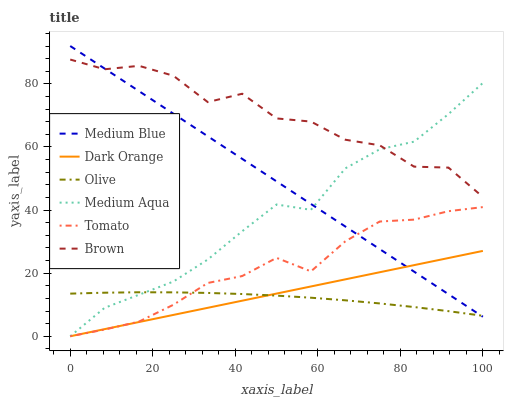Does Olive have the minimum area under the curve?
Answer yes or no. Yes. Does Brown have the maximum area under the curve?
Answer yes or no. Yes. Does Dark Orange have the minimum area under the curve?
Answer yes or no. No. Does Dark Orange have the maximum area under the curve?
Answer yes or no. No. Is Dark Orange the smoothest?
Answer yes or no. Yes. Is Brown the roughest?
Answer yes or no. Yes. Is Brown the smoothest?
Answer yes or no. No. Is Dark Orange the roughest?
Answer yes or no. No. Does Tomato have the lowest value?
Answer yes or no. Yes. Does Brown have the lowest value?
Answer yes or no. No. Does Medium Blue have the highest value?
Answer yes or no. Yes. Does Dark Orange have the highest value?
Answer yes or no. No. Is Dark Orange less than Brown?
Answer yes or no. Yes. Is Brown greater than Tomato?
Answer yes or no. Yes. Does Olive intersect Dark Orange?
Answer yes or no. Yes. Is Olive less than Dark Orange?
Answer yes or no. No. Is Olive greater than Dark Orange?
Answer yes or no. No. Does Dark Orange intersect Brown?
Answer yes or no. No. 